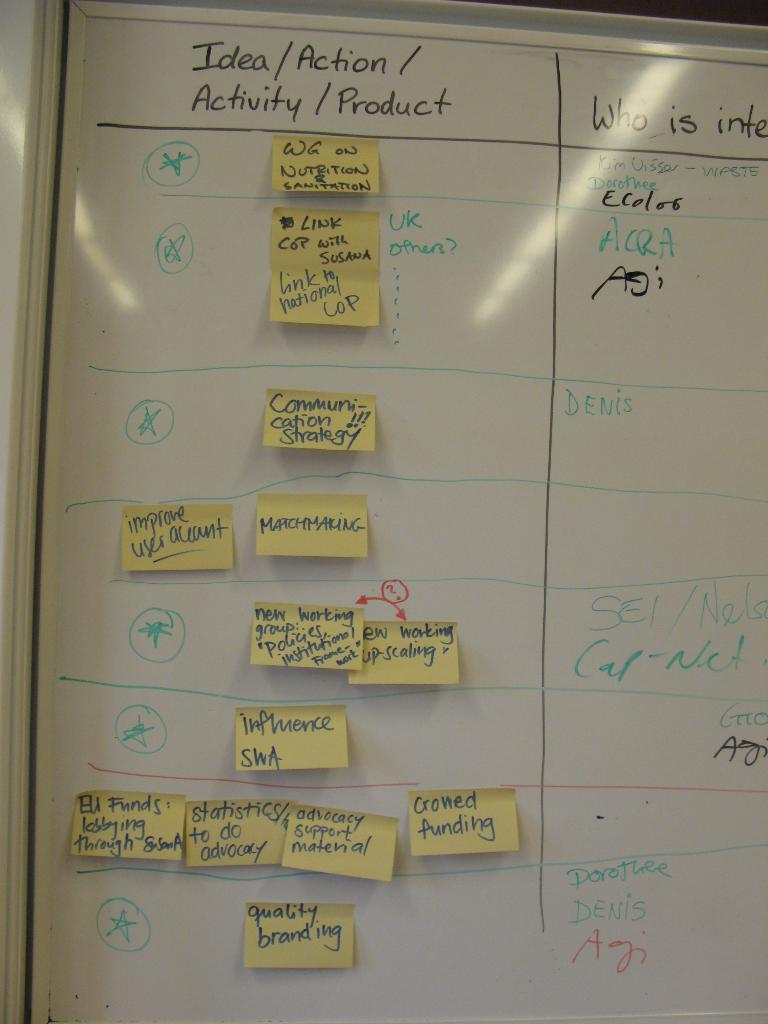<image>
Offer a succinct explanation of the picture presented. a portion of a whiteboard with a heading of Idea/action/activity/product on it 